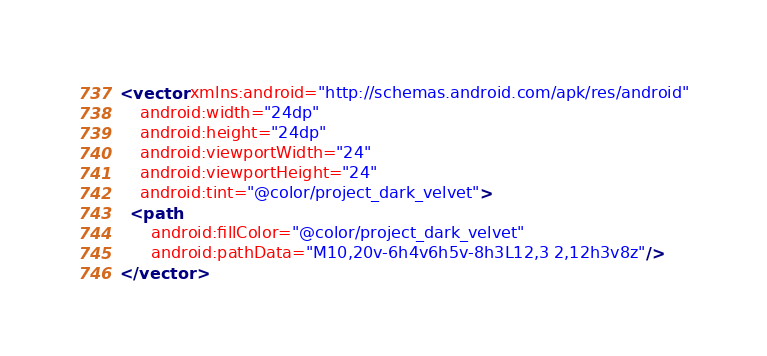Convert code to text. <code><loc_0><loc_0><loc_500><loc_500><_XML_><vector xmlns:android="http://schemas.android.com/apk/res/android"
    android:width="24dp"
    android:height="24dp"
    android:viewportWidth="24"
    android:viewportHeight="24"
    android:tint="@color/project_dark_velvet">
  <path
      android:fillColor="@color/project_dark_velvet"
      android:pathData="M10,20v-6h4v6h5v-8h3L12,3 2,12h3v8z"/>
</vector>
</code> 